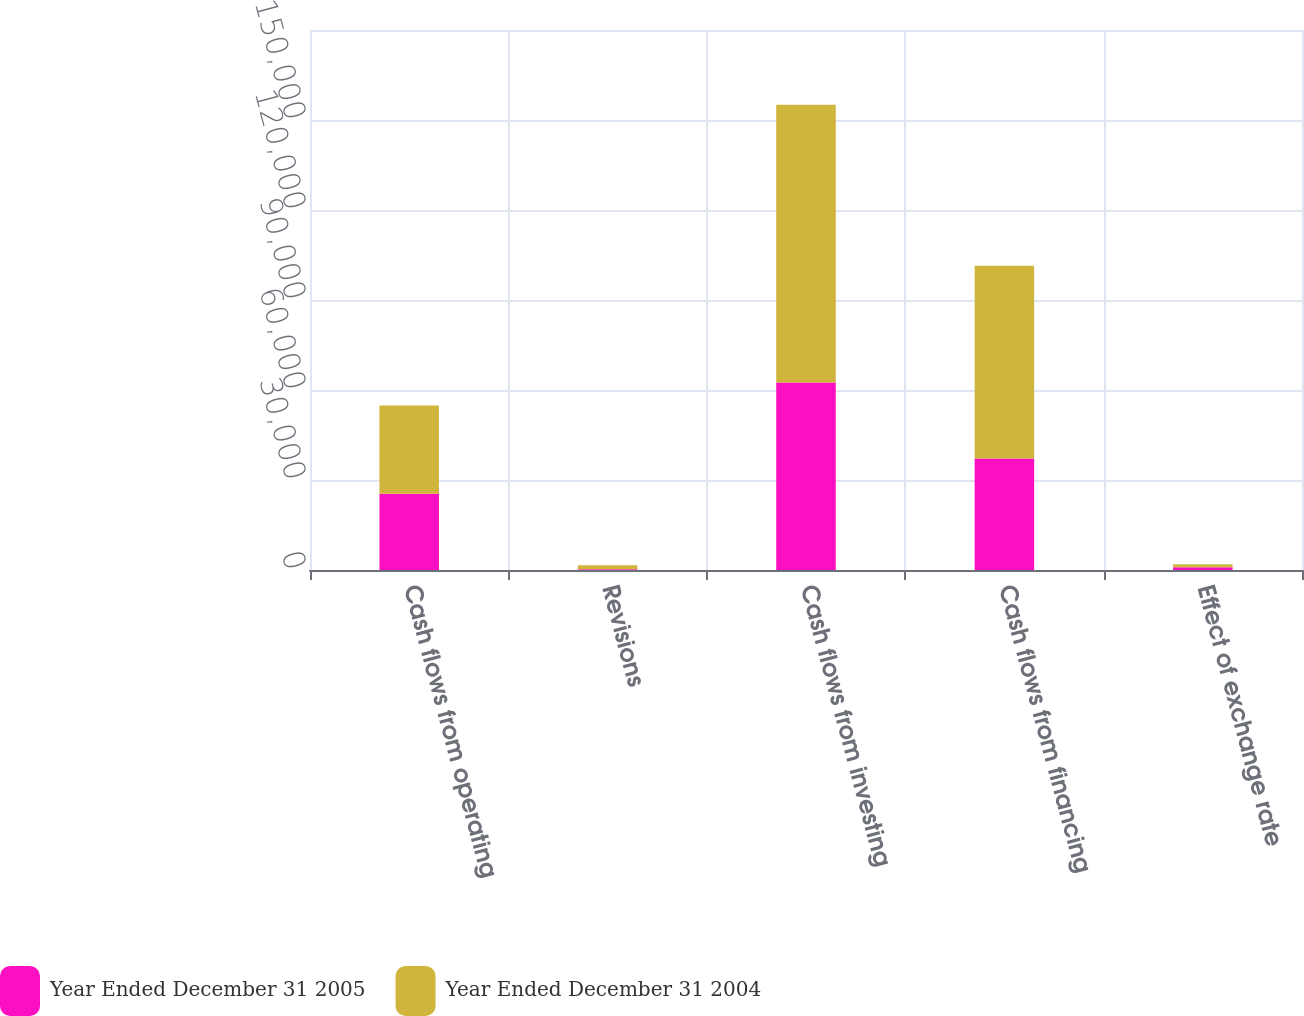Convert chart. <chart><loc_0><loc_0><loc_500><loc_500><stacked_bar_chart><ecel><fcel>Cash flows from operating<fcel>Revisions<fcel>Cash flows from investing<fcel>Cash flows from financing<fcel>Effect of exchange rate<nl><fcel>Year Ended December 31 2005<fcel>25382<fcel>244<fcel>62500<fcel>37169<fcel>928<nl><fcel>Year Ended December 31 2004<fcel>29414<fcel>1302<fcel>92596<fcel>64217<fcel>992<nl></chart> 